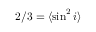Convert formula to latex. <formula><loc_0><loc_0><loc_500><loc_500>2 / 3 = \langle \sin ^ { 2 } i \rangle</formula> 